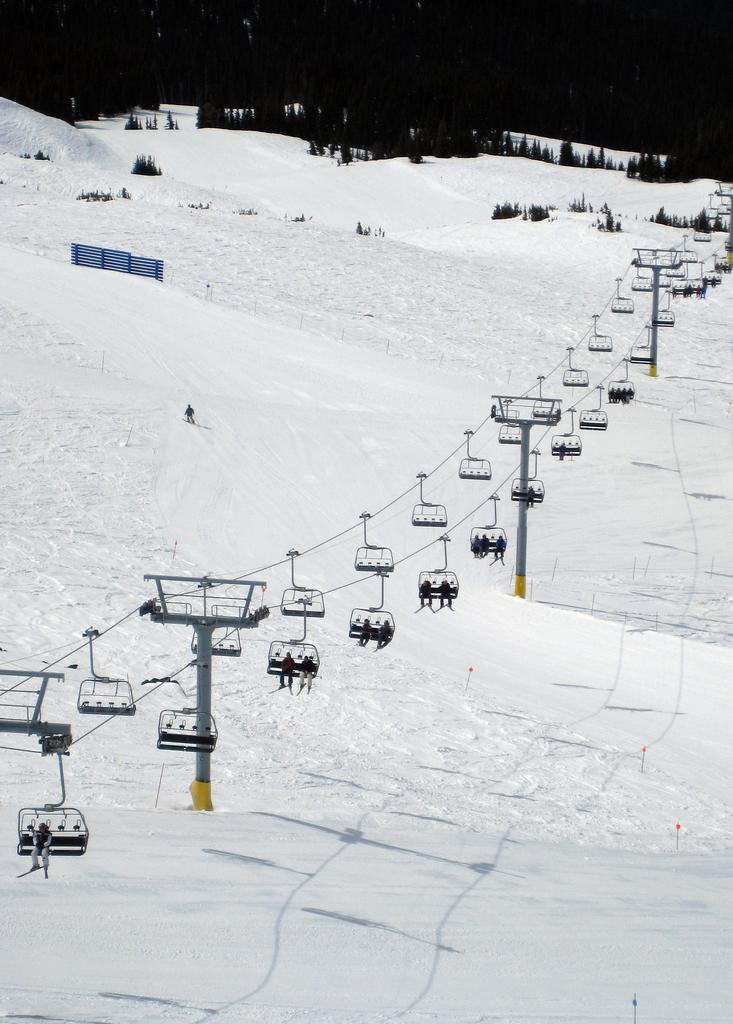What is the main subject in the center of the image? There is a ropeway in the center of the image. What can be seen at the bottom of the image? There is snow at the bottom of the image. What type of natural environment is visible in the background of the image? There are trees in the background of the image. What type of sense can be seen in the image? There is no sense visible in the image; it features a ropeway, snow, and trees. Where is the bedroom located in the image? There is no bedroom present in the image. 